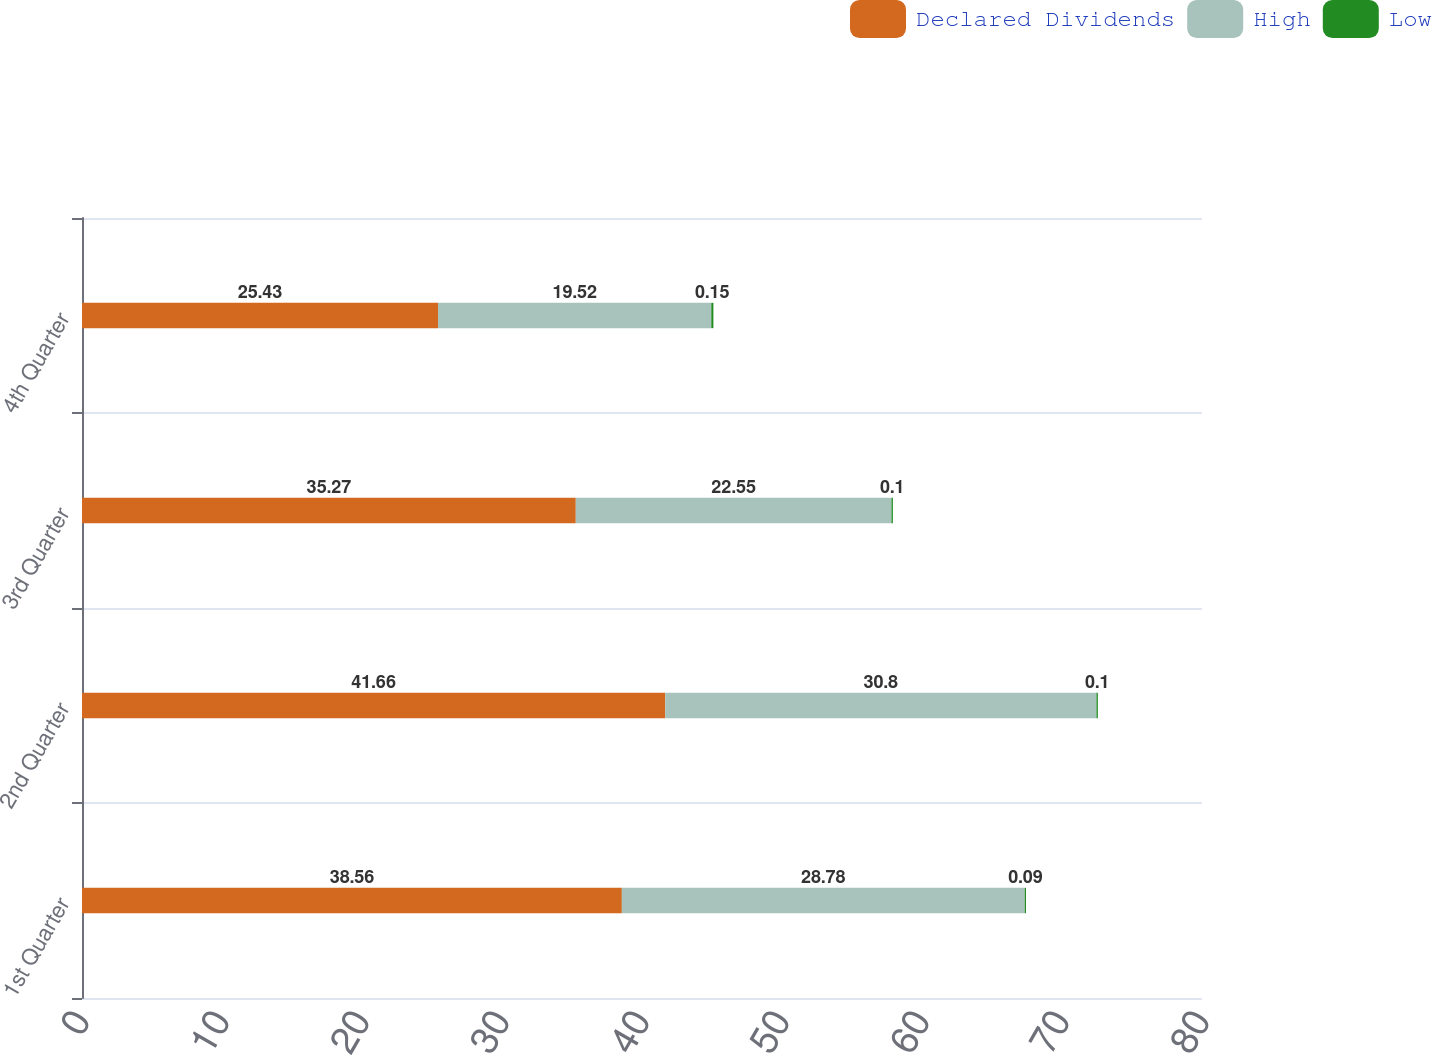Convert chart. <chart><loc_0><loc_0><loc_500><loc_500><stacked_bar_chart><ecel><fcel>1st Quarter<fcel>2nd Quarter<fcel>3rd Quarter<fcel>4th Quarter<nl><fcel>Declared Dividends<fcel>38.56<fcel>41.66<fcel>35.27<fcel>25.43<nl><fcel>High<fcel>28.78<fcel>30.8<fcel>22.55<fcel>19.52<nl><fcel>Low<fcel>0.09<fcel>0.1<fcel>0.1<fcel>0.15<nl></chart> 